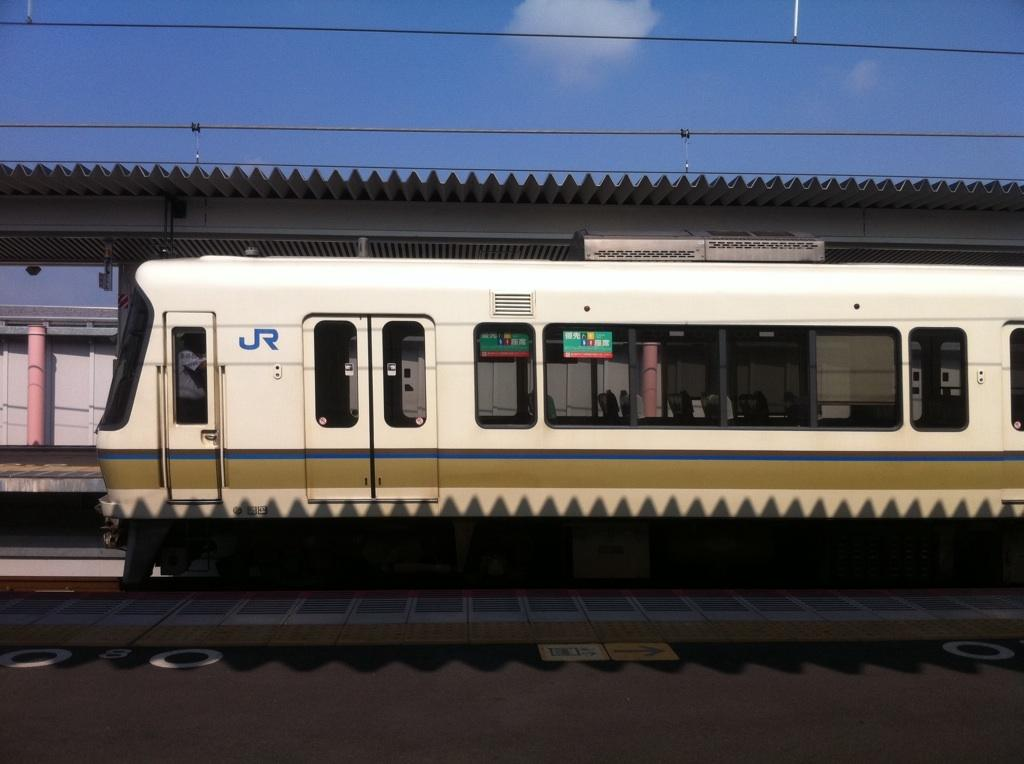What is the main subject of the image? The main subject of the image is a train. What else can be seen in the image besides the train? There is a platform, a shelter, a pole, and the sky visible at the top of the image. What might be used to provide shade or protection from the elements? The shelter in the image can provide shade or protection from the elements. What is present at the top of the image? The sky and wires are present at the top of the image. What type of hospital is located near the train station in the image? There is no hospital present in the image; it only features a train, platform, shelter, pole, sky, and wires. 